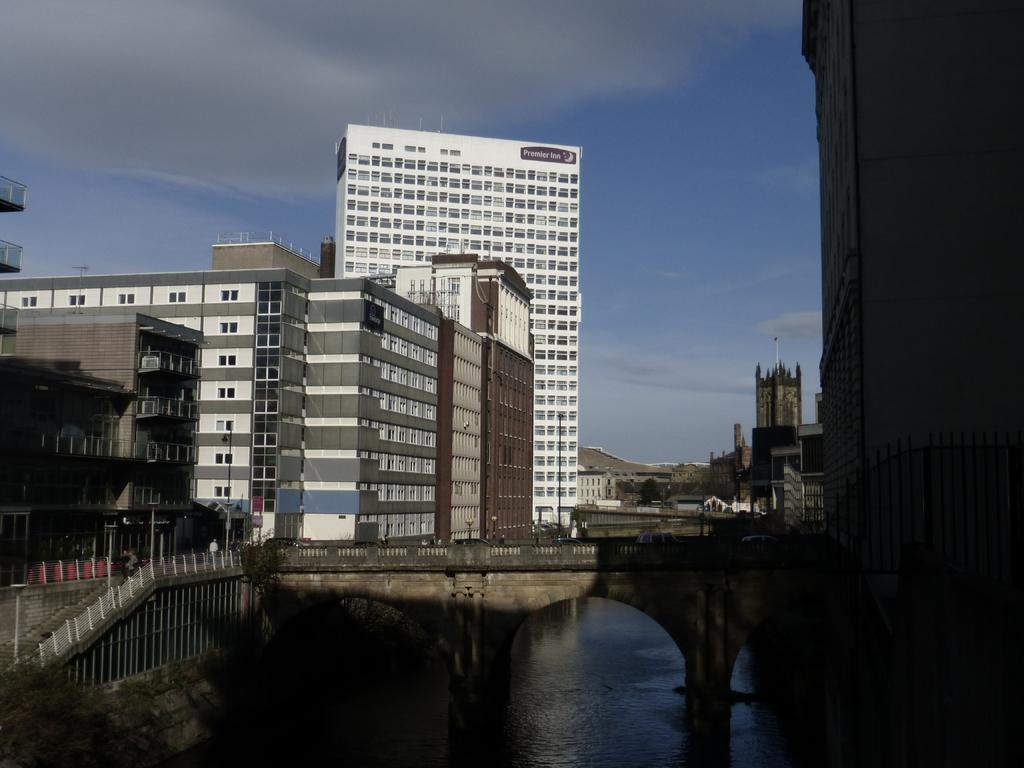What type of structures can be seen in the image? There are buildings in the image. What architectural feature is present in the image? There are stairs and a railing in the image. What type of passageway is depicted in the image? There is a bridge in the image. What can be seen in the background of the image? The sky is visible in the background of the image, and there are clouds in the sky. What natural element is visible at the bottom of the image? There is water visible at the bottom of the image. What type of representative circle is present in the image? There is no representative circle present in the image. What team is depicted playing on the bridge in the image? There is no team or any indication of a game being played in the image. 